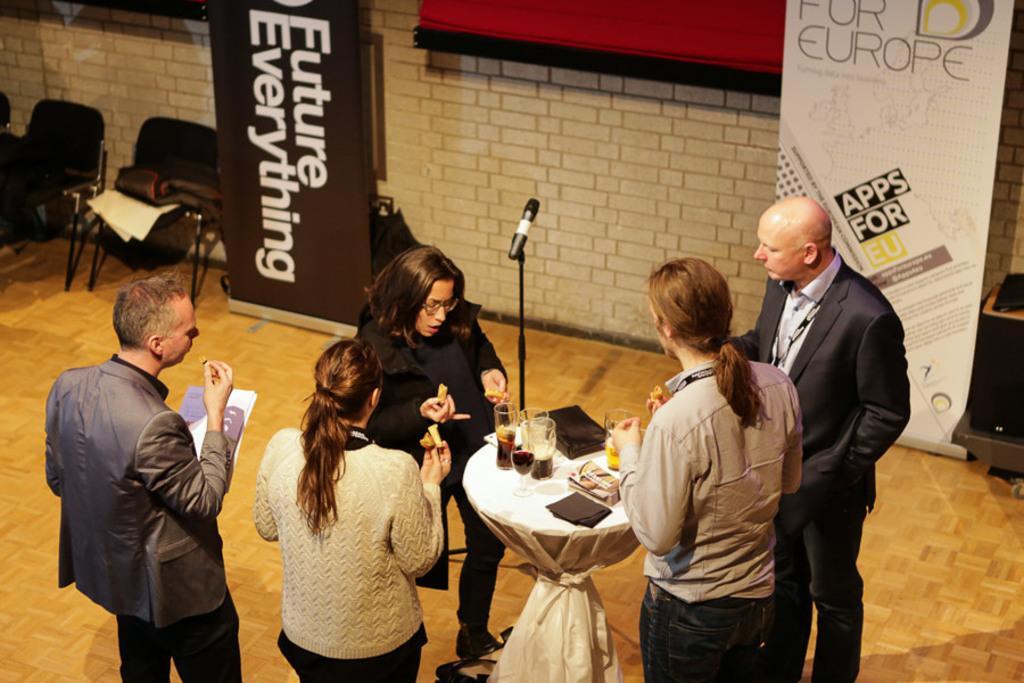How would you summarize this image in a sentence or two? As we can see in the image there are chairs, banners, building, group of people, mic and table. On table there is white color cloth and glasses. 